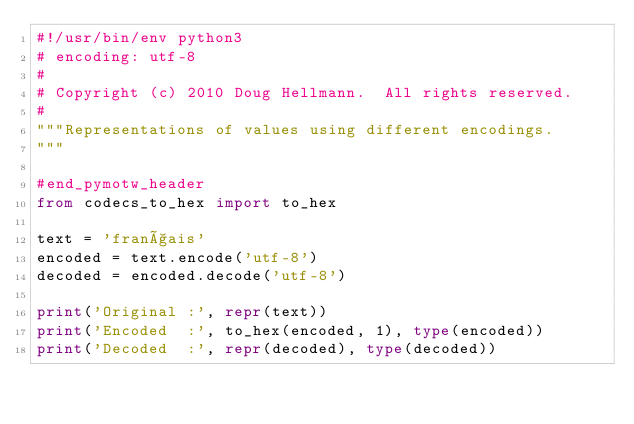Convert code to text. <code><loc_0><loc_0><loc_500><loc_500><_Python_>#!/usr/bin/env python3
# encoding: utf-8
#
# Copyright (c) 2010 Doug Hellmann.  All rights reserved.
#
"""Representations of values using different encodings.
"""

#end_pymotw_header
from codecs_to_hex import to_hex

text = 'français'
encoded = text.encode('utf-8')
decoded = encoded.decode('utf-8')

print('Original :', repr(text))
print('Encoded  :', to_hex(encoded, 1), type(encoded))
print('Decoded  :', repr(decoded), type(decoded))
</code> 